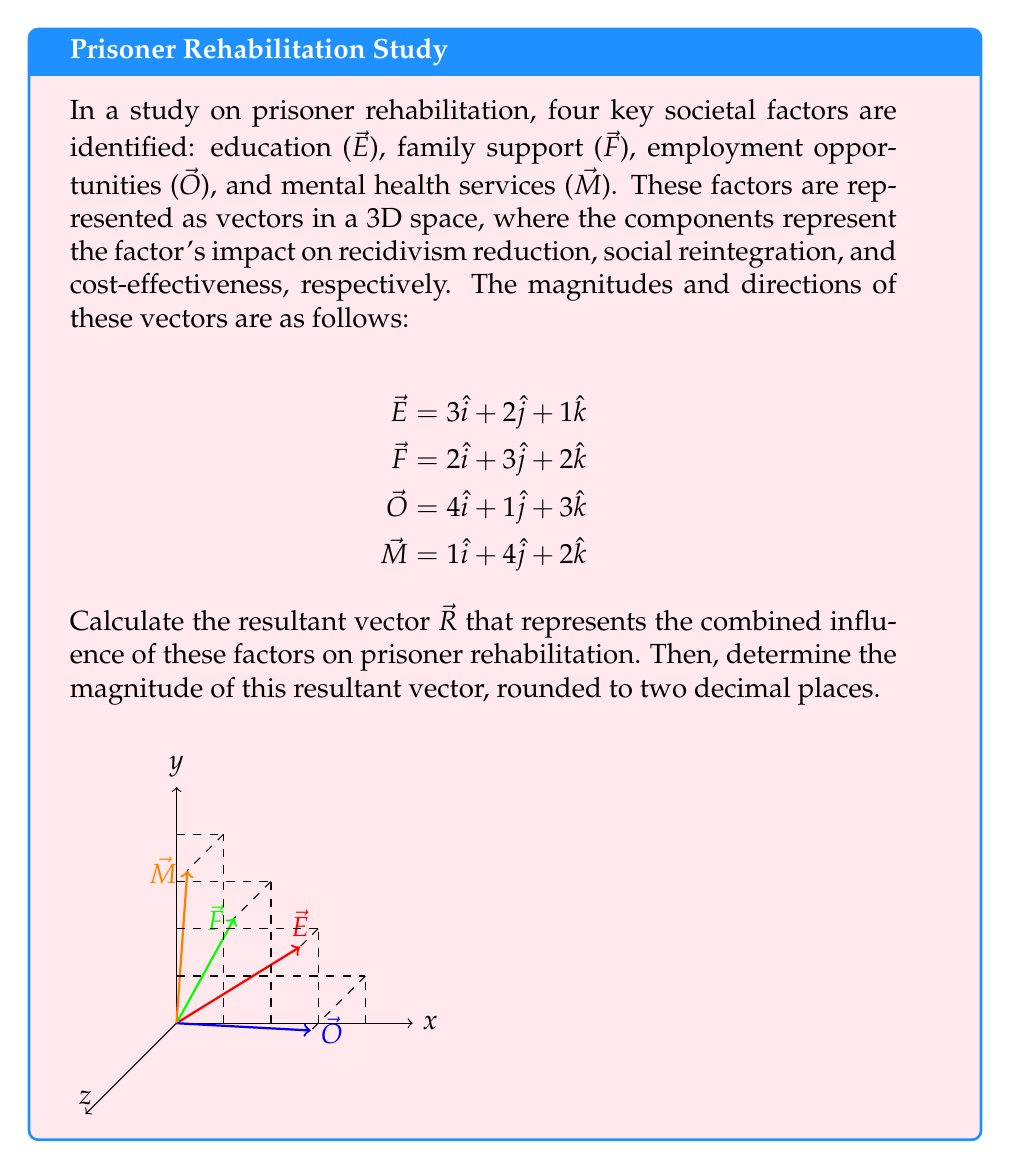Provide a solution to this math problem. To solve this problem, we'll follow these steps:

1) First, we need to add all the vectors to find the resultant vector $\vec{R}$. We can do this by adding the components of each vector:

   $\vec{R} = \vec{E} + \vec{F} + \vec{O} + \vec{M}$

   $\vec{R} = (3\hat{i} + 2\hat{j} + 1\hat{k}) + (2\hat{i} + 3\hat{j} + 2\hat{k}) + (4\hat{i} + 1\hat{j} + 3\hat{k}) + (1\hat{i} + 4\hat{j} + 2\hat{k})$

2) Now, let's add up the components:

   $\vec{R} = (3+2+4+1)\hat{i} + (2+3+1+4)\hat{j} + (1+2+3+2)\hat{k}$

   $\vec{R} = 10\hat{i} + 10\hat{j} + 8\hat{k}$

3) To find the magnitude of the resultant vector, we use the formula:

   $|\vec{R}| = \sqrt{x^2 + y^2 + z^2}$

   Where x, y, and z are the components of the vector.

4) Substituting our values:

   $|\vec{R}| = \sqrt{10^2 + 10^2 + 8^2}$

5) Simplify:

   $|\vec{R}| = \sqrt{100 + 100 + 64} = \sqrt{264}$

6) Calculate and round to two decimal places:

   $|\vec{R}| \approx 16.25$
Answer: $\vec{R} = 10\hat{i} + 10\hat{j} + 8\hat{k}$, $|\vec{R}| \approx 16.25$ 